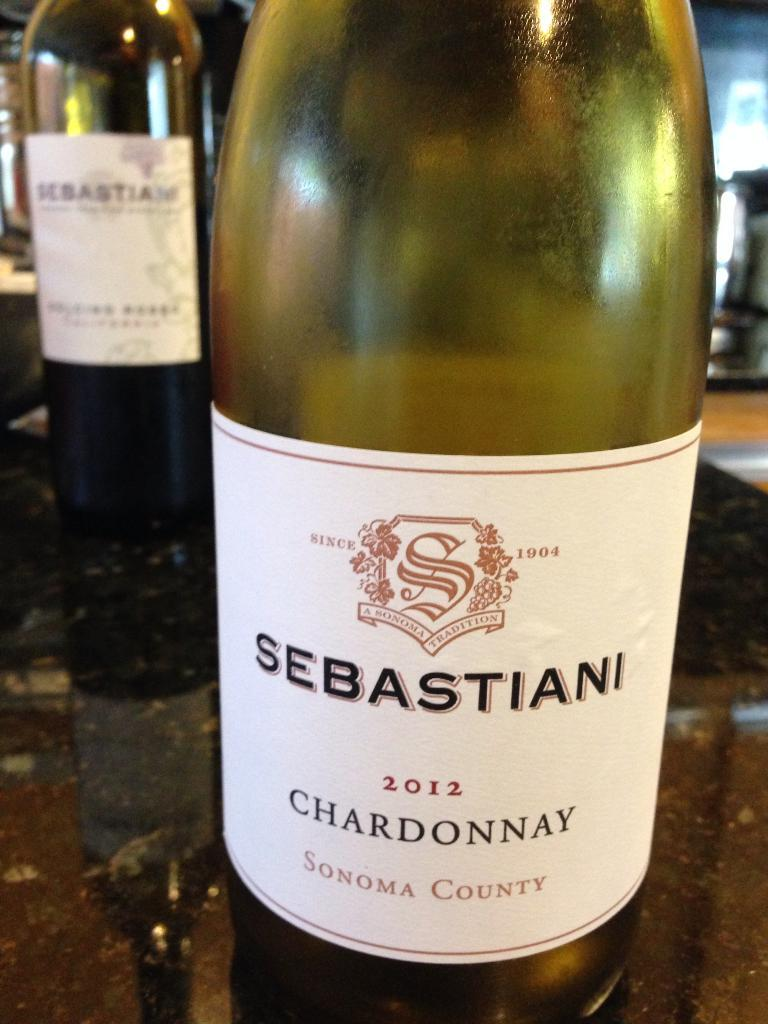<image>
Write a terse but informative summary of the picture. the word sebastiani that is on a bottle 